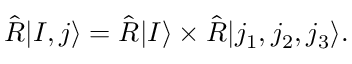<formula> <loc_0><loc_0><loc_500><loc_500>\hat { R } | I , j \rangle = \hat { R } | I \rangle \times \hat { R } | j _ { 1 } , j _ { 2 } , j _ { 3 } \rangle .</formula> 